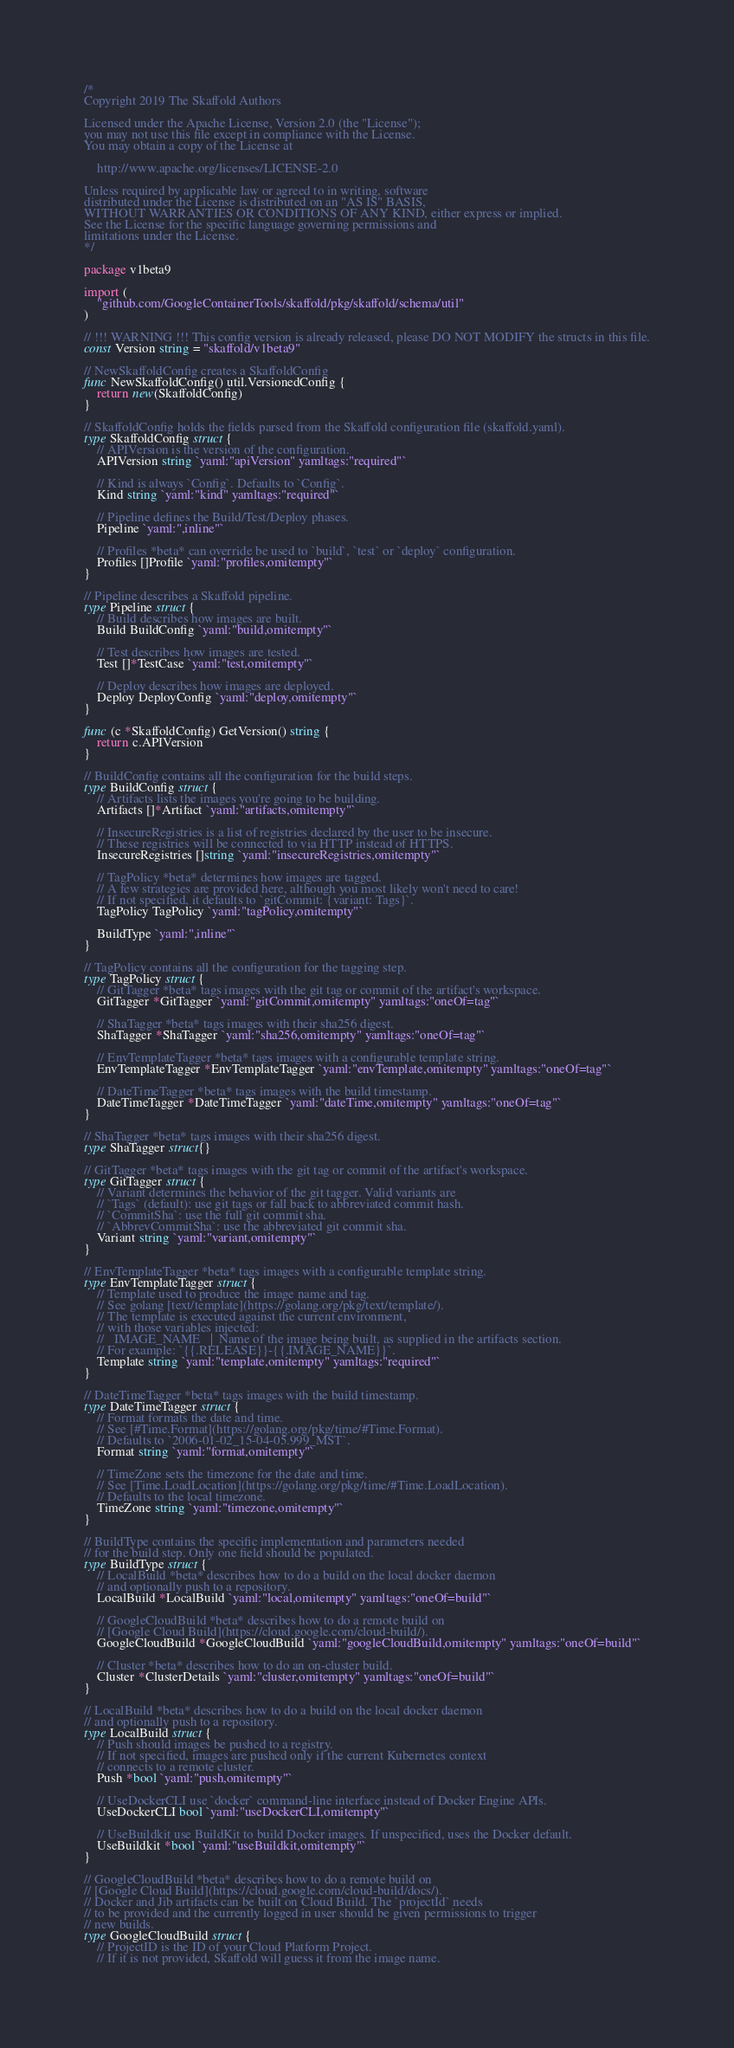<code> <loc_0><loc_0><loc_500><loc_500><_Go_>/*
Copyright 2019 The Skaffold Authors

Licensed under the Apache License, Version 2.0 (the "License");
you may not use this file except in compliance with the License.
You may obtain a copy of the License at

    http://www.apache.org/licenses/LICENSE-2.0

Unless required by applicable law or agreed to in writing, software
distributed under the License is distributed on an "AS IS" BASIS,
WITHOUT WARRANTIES OR CONDITIONS OF ANY KIND, either express or implied.
See the License for the specific language governing permissions and
limitations under the License.
*/

package v1beta9

import (
	"github.com/GoogleContainerTools/skaffold/pkg/skaffold/schema/util"
)

// !!! WARNING !!! This config version is already released, please DO NOT MODIFY the structs in this file.
const Version string = "skaffold/v1beta9"

// NewSkaffoldConfig creates a SkaffoldConfig
func NewSkaffoldConfig() util.VersionedConfig {
	return new(SkaffoldConfig)
}

// SkaffoldConfig holds the fields parsed from the Skaffold configuration file (skaffold.yaml).
type SkaffoldConfig struct {
	// APIVersion is the version of the configuration.
	APIVersion string `yaml:"apiVersion" yamltags:"required"`

	// Kind is always `Config`. Defaults to `Config`.
	Kind string `yaml:"kind" yamltags:"required"`

	// Pipeline defines the Build/Test/Deploy phases.
	Pipeline `yaml:",inline"`

	// Profiles *beta* can override be used to `build`, `test` or `deploy` configuration.
	Profiles []Profile `yaml:"profiles,omitempty"`
}

// Pipeline describes a Skaffold pipeline.
type Pipeline struct {
	// Build describes how images are built.
	Build BuildConfig `yaml:"build,omitempty"`

	// Test describes how images are tested.
	Test []*TestCase `yaml:"test,omitempty"`

	// Deploy describes how images are deployed.
	Deploy DeployConfig `yaml:"deploy,omitempty"`
}

func (c *SkaffoldConfig) GetVersion() string {
	return c.APIVersion
}

// BuildConfig contains all the configuration for the build steps.
type BuildConfig struct {
	// Artifacts lists the images you're going to be building.
	Artifacts []*Artifact `yaml:"artifacts,omitempty"`

	// InsecureRegistries is a list of registries declared by the user to be insecure.
	// These registries will be connected to via HTTP instead of HTTPS.
	InsecureRegistries []string `yaml:"insecureRegistries,omitempty"`

	// TagPolicy *beta* determines how images are tagged.
	// A few strategies are provided here, although you most likely won't need to care!
	// If not specified, it defaults to `gitCommit: {variant: Tags}`.
	TagPolicy TagPolicy `yaml:"tagPolicy,omitempty"`

	BuildType `yaml:",inline"`
}

// TagPolicy contains all the configuration for the tagging step.
type TagPolicy struct {
	// GitTagger *beta* tags images with the git tag or commit of the artifact's workspace.
	GitTagger *GitTagger `yaml:"gitCommit,omitempty" yamltags:"oneOf=tag"`

	// ShaTagger *beta* tags images with their sha256 digest.
	ShaTagger *ShaTagger `yaml:"sha256,omitempty" yamltags:"oneOf=tag"`

	// EnvTemplateTagger *beta* tags images with a configurable template string.
	EnvTemplateTagger *EnvTemplateTagger `yaml:"envTemplate,omitempty" yamltags:"oneOf=tag"`

	// DateTimeTagger *beta* tags images with the build timestamp.
	DateTimeTagger *DateTimeTagger `yaml:"dateTime,omitempty" yamltags:"oneOf=tag"`
}

// ShaTagger *beta* tags images with their sha256 digest.
type ShaTagger struct{}

// GitTagger *beta* tags images with the git tag or commit of the artifact's workspace.
type GitTagger struct {
	// Variant determines the behavior of the git tagger. Valid variants are
	// `Tags` (default): use git tags or fall back to abbreviated commit hash.
	// `CommitSha`: use the full git commit sha.
	// `AbbrevCommitSha`: use the abbreviated git commit sha.
	Variant string `yaml:"variant,omitempty"`
}

// EnvTemplateTagger *beta* tags images with a configurable template string.
type EnvTemplateTagger struct {
	// Template used to produce the image name and tag.
	// See golang [text/template](https://golang.org/pkg/text/template/).
	// The template is executed against the current environment,
	// with those variables injected:
	//   IMAGE_NAME   |  Name of the image being built, as supplied in the artifacts section.
	// For example: `{{.RELEASE}}-{{.IMAGE_NAME}}`.
	Template string `yaml:"template,omitempty" yamltags:"required"`
}

// DateTimeTagger *beta* tags images with the build timestamp.
type DateTimeTagger struct {
	// Format formats the date and time.
	// See [#Time.Format](https://golang.org/pkg/time/#Time.Format).
	// Defaults to `2006-01-02_15-04-05.999_MST`.
	Format string `yaml:"format,omitempty"`

	// TimeZone sets the timezone for the date and time.
	// See [Time.LoadLocation](https://golang.org/pkg/time/#Time.LoadLocation).
	// Defaults to the local timezone.
	TimeZone string `yaml:"timezone,omitempty"`
}

// BuildType contains the specific implementation and parameters needed
// for the build step. Only one field should be populated.
type BuildType struct {
	// LocalBuild *beta* describes how to do a build on the local docker daemon
	// and optionally push to a repository.
	LocalBuild *LocalBuild `yaml:"local,omitempty" yamltags:"oneOf=build"`

	// GoogleCloudBuild *beta* describes how to do a remote build on
	// [Google Cloud Build](https://cloud.google.com/cloud-build/).
	GoogleCloudBuild *GoogleCloudBuild `yaml:"googleCloudBuild,omitempty" yamltags:"oneOf=build"`

	// Cluster *beta* describes how to do an on-cluster build.
	Cluster *ClusterDetails `yaml:"cluster,omitempty" yamltags:"oneOf=build"`
}

// LocalBuild *beta* describes how to do a build on the local docker daemon
// and optionally push to a repository.
type LocalBuild struct {
	// Push should images be pushed to a registry.
	// If not specified, images are pushed only if the current Kubernetes context
	// connects to a remote cluster.
	Push *bool `yaml:"push,omitempty"`

	// UseDockerCLI use `docker` command-line interface instead of Docker Engine APIs.
	UseDockerCLI bool `yaml:"useDockerCLI,omitempty"`

	// UseBuildkit use BuildKit to build Docker images. If unspecified, uses the Docker default.
	UseBuildkit *bool `yaml:"useBuildkit,omitempty"`
}

// GoogleCloudBuild *beta* describes how to do a remote build on
// [Google Cloud Build](https://cloud.google.com/cloud-build/docs/).
// Docker and Jib artifacts can be built on Cloud Build. The `projectId` needs
// to be provided and the currently logged in user should be given permissions to trigger
// new builds.
type GoogleCloudBuild struct {
	// ProjectID is the ID of your Cloud Platform Project.
	// If it is not provided, Skaffold will guess it from the image name.</code> 